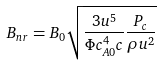<formula> <loc_0><loc_0><loc_500><loc_500>B _ { n r } = B _ { 0 } \sqrt { \frac { 3 u ^ { 5 } } { \Phi c _ { A 0 } ^ { 4 } c } \frac { P _ { c } } { \rho u ^ { 2 } } }</formula> 